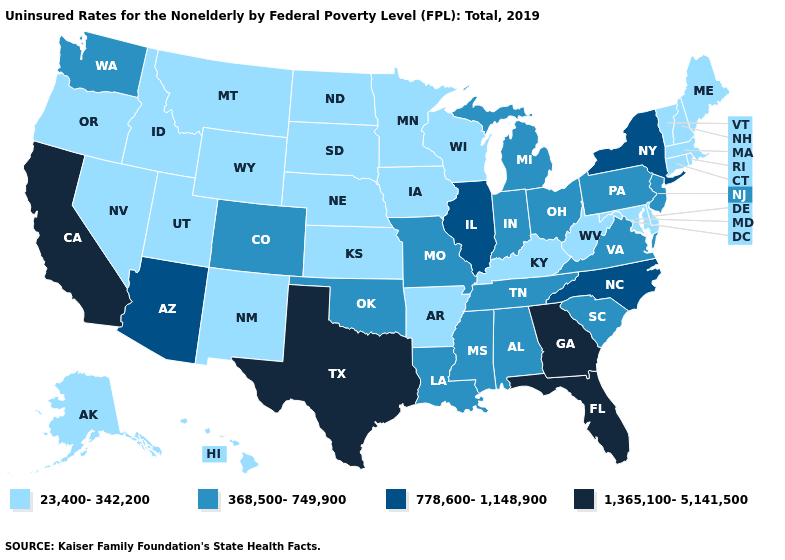Among the states that border New Mexico , does Utah have the highest value?
Answer briefly. No. Does Alabama have a higher value than Illinois?
Write a very short answer. No. Among the states that border Nebraska , does Wyoming have the highest value?
Answer briefly. No. What is the highest value in the USA?
Concise answer only. 1,365,100-5,141,500. Name the states that have a value in the range 778,600-1,148,900?
Write a very short answer. Arizona, Illinois, New York, North Carolina. Name the states that have a value in the range 778,600-1,148,900?
Concise answer only. Arizona, Illinois, New York, North Carolina. Does West Virginia have the lowest value in the USA?
Keep it brief. Yes. How many symbols are there in the legend?
Answer briefly. 4. Does Delaware have the lowest value in the USA?
Quick response, please. Yes. What is the value of North Dakota?
Short answer required. 23,400-342,200. Among the states that border Kansas , which have the highest value?
Be succinct. Colorado, Missouri, Oklahoma. Does Kentucky have a higher value than Maryland?
Write a very short answer. No. What is the highest value in the USA?
Concise answer only. 1,365,100-5,141,500. Name the states that have a value in the range 778,600-1,148,900?
Short answer required. Arizona, Illinois, New York, North Carolina. Which states hav the highest value in the West?
Keep it brief. California. 